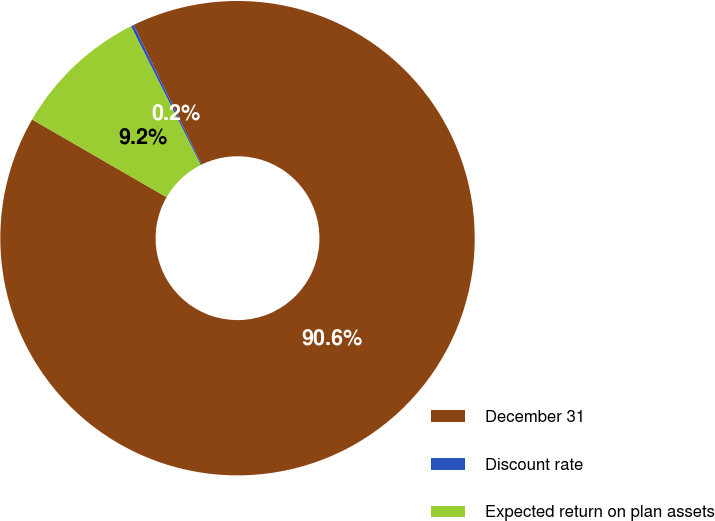Convert chart to OTSL. <chart><loc_0><loc_0><loc_500><loc_500><pie_chart><fcel>December 31<fcel>Discount rate<fcel>Expected return on plan assets<nl><fcel>90.56%<fcel>0.2%<fcel>9.24%<nl></chart> 